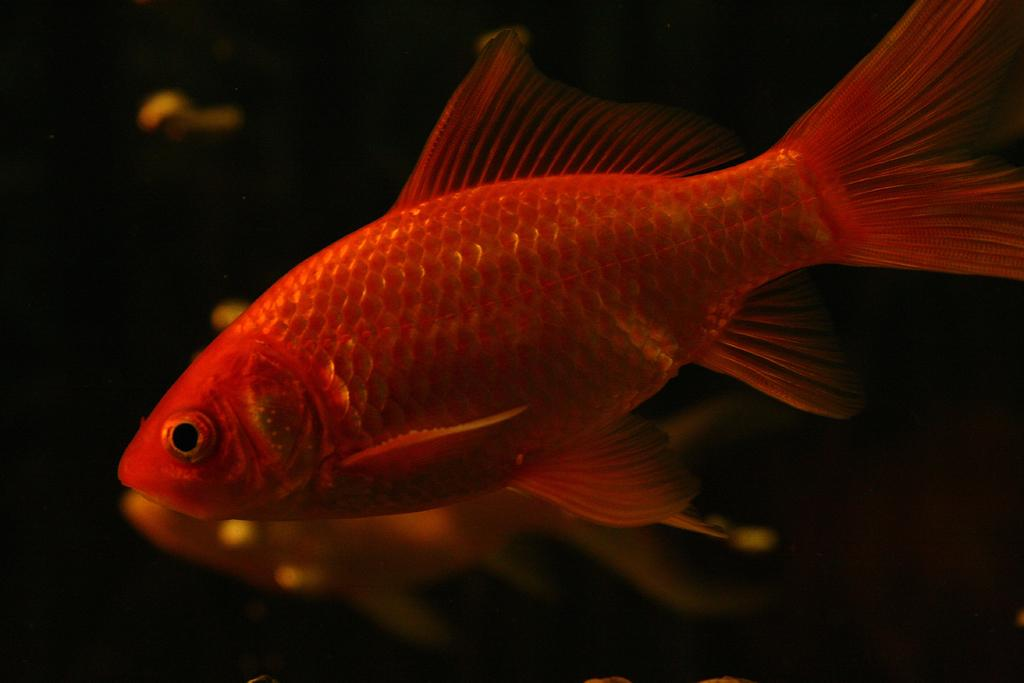What type of animals can be seen in the water in the image? There are fishes in the water. What is the primary element in which the fishes are situated? The fishes are situated in water. What type of basket can be seen in the image? There is no basket present in the image; it features fishes in the water. What adjustments are being made to the fishes in the image? There are no adjustments being made to the fishes in the image; they are simply swimming in the water. 